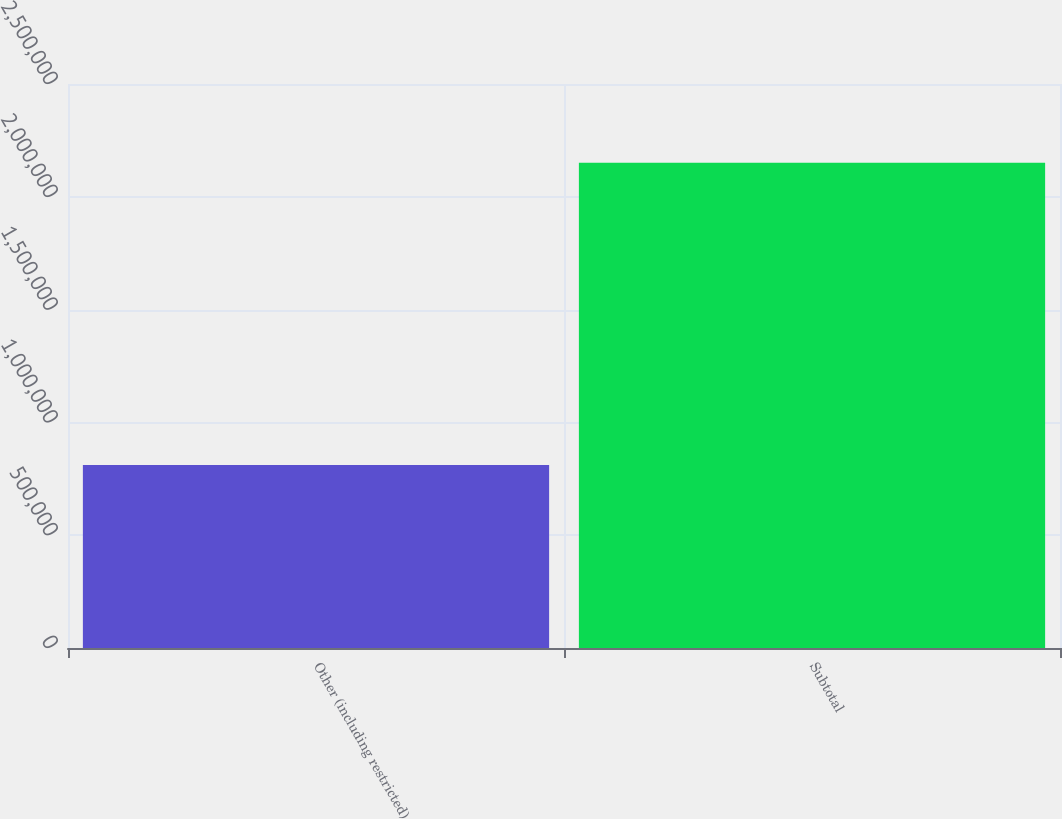Convert chart. <chart><loc_0><loc_0><loc_500><loc_500><bar_chart><fcel>Other (including restricted)<fcel>Subtotal<nl><fcel>810883<fcel>2.151e+06<nl></chart> 